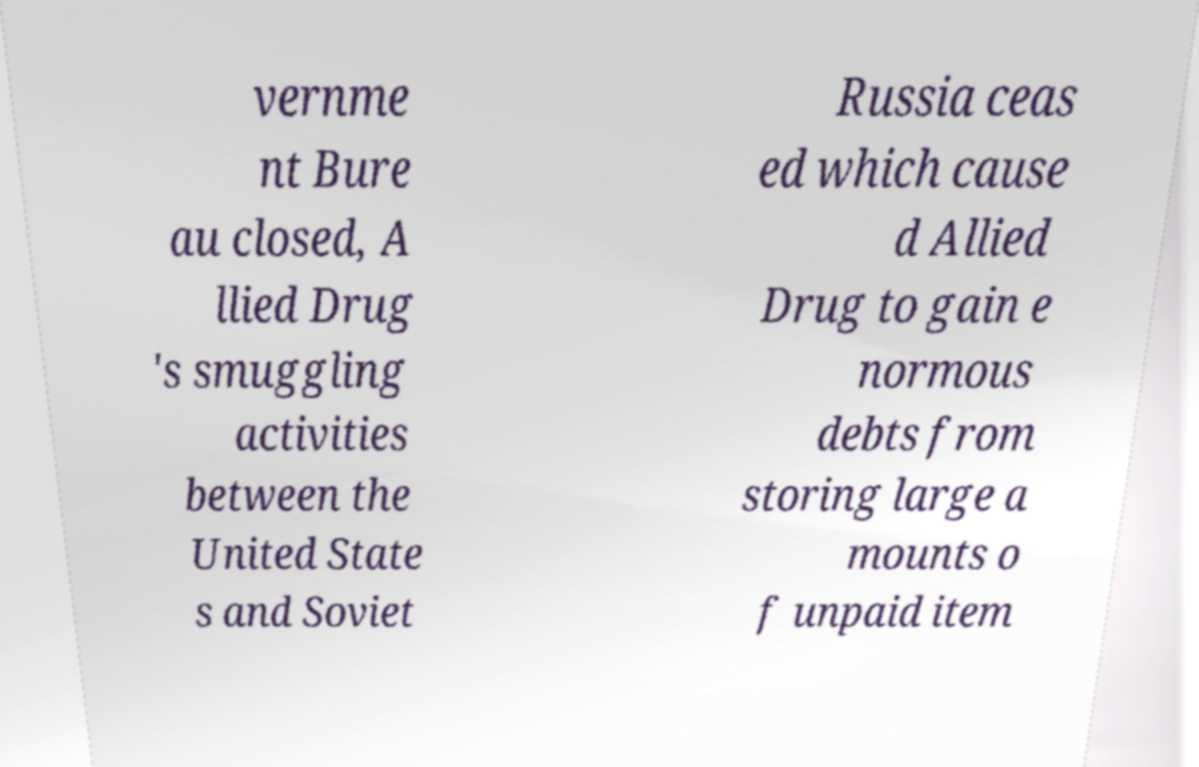What messages or text are displayed in this image? I need them in a readable, typed format. vernme nt Bure au closed, A llied Drug 's smuggling activities between the United State s and Soviet Russia ceas ed which cause d Allied Drug to gain e normous debts from storing large a mounts o f unpaid item 